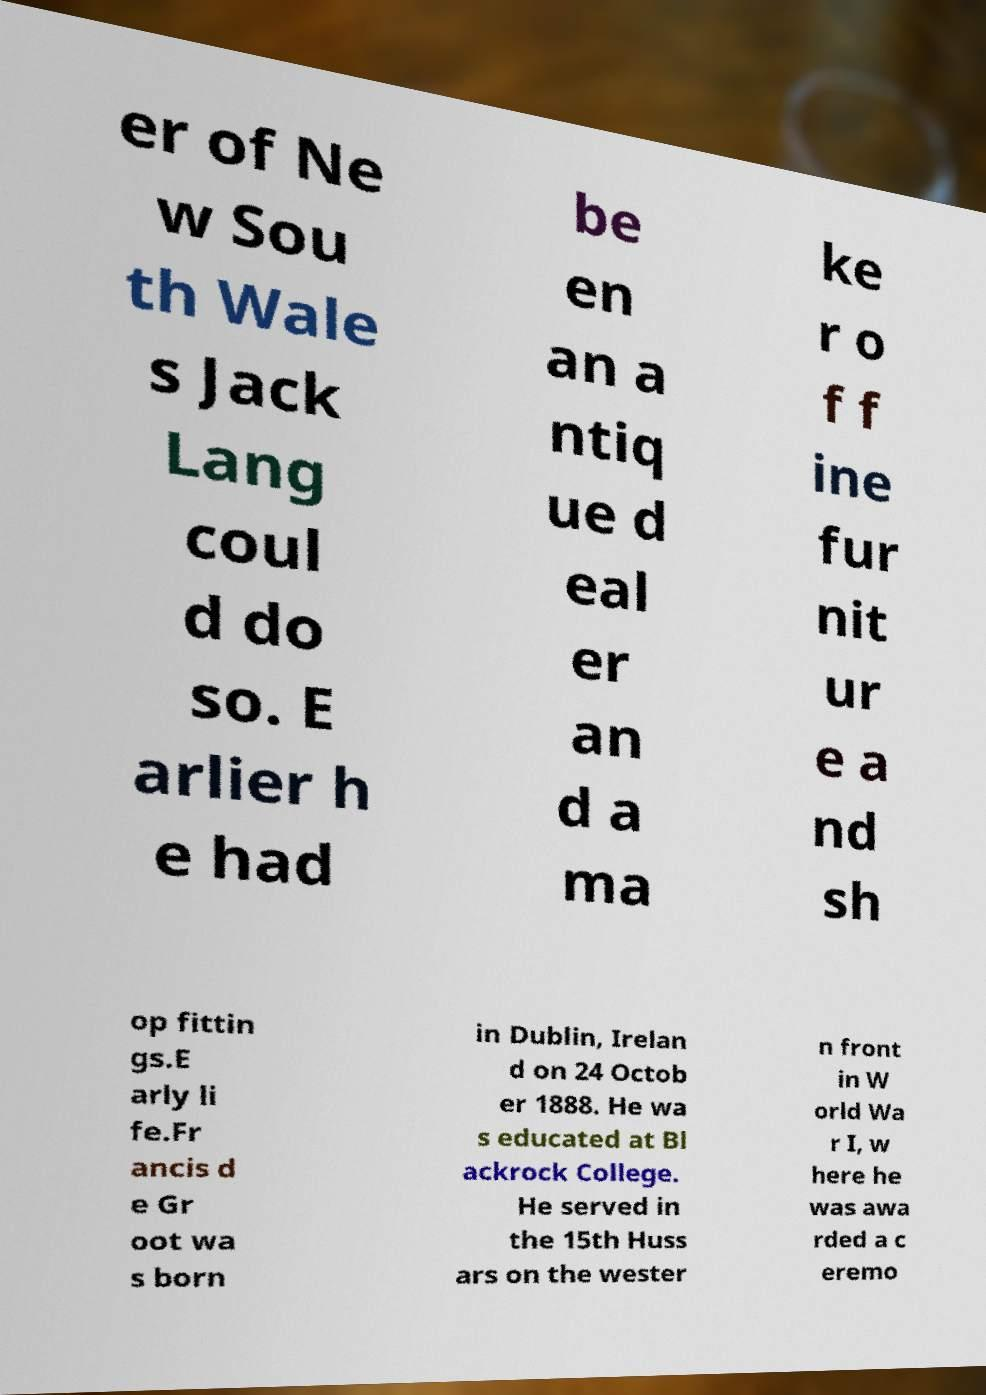For documentation purposes, I need the text within this image transcribed. Could you provide that? er of Ne w Sou th Wale s Jack Lang coul d do so. E arlier h e had be en an a ntiq ue d eal er an d a ma ke r o f f ine fur nit ur e a nd sh op fittin gs.E arly li fe.Fr ancis d e Gr oot wa s born in Dublin, Irelan d on 24 Octob er 1888. He wa s educated at Bl ackrock College. He served in the 15th Huss ars on the wester n front in W orld Wa r I, w here he was awa rded a c eremo 